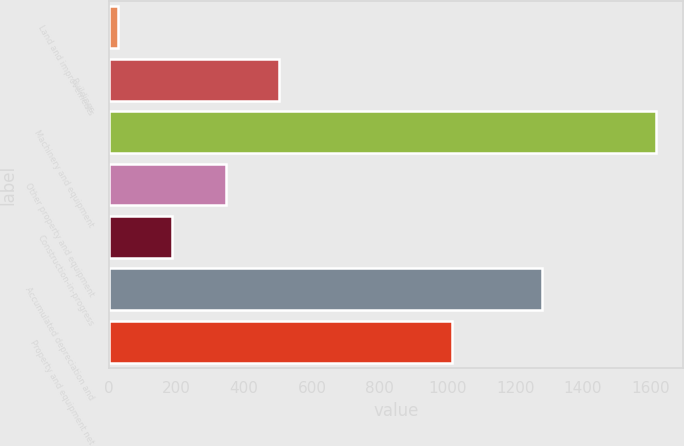Convert chart. <chart><loc_0><loc_0><loc_500><loc_500><bar_chart><fcel>Land and improvements<fcel>Buildings<fcel>Machinery and equipment<fcel>Other property and equipment<fcel>Construction-in-progress<fcel>Accumulated depreciation and<fcel>Property and equipment net<nl><fcel>27.4<fcel>503.98<fcel>1616<fcel>345.12<fcel>186.26<fcel>1279.5<fcel>1013<nl></chart> 